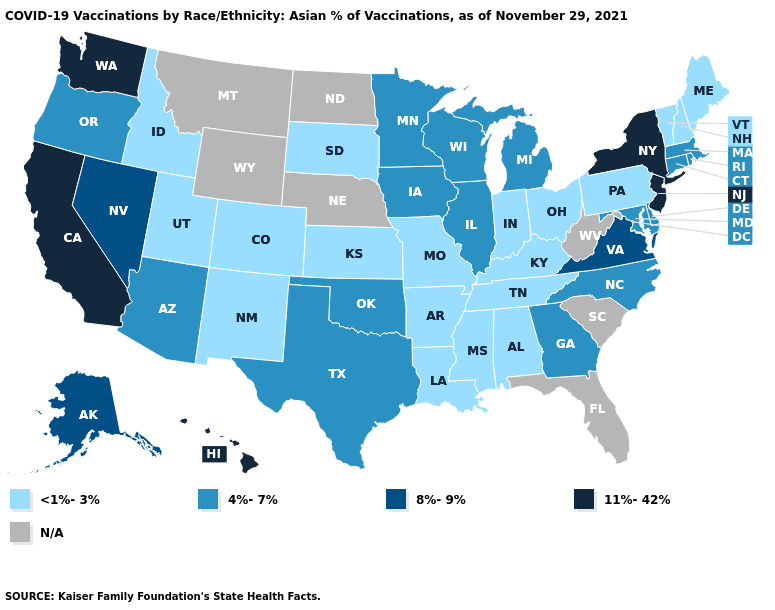Name the states that have a value in the range 4%-7%?
Answer briefly. Arizona, Connecticut, Delaware, Georgia, Illinois, Iowa, Maryland, Massachusetts, Michigan, Minnesota, North Carolina, Oklahoma, Oregon, Rhode Island, Texas, Wisconsin. What is the highest value in the MidWest ?
Answer briefly. 4%-7%. Name the states that have a value in the range N/A?
Be succinct. Florida, Montana, Nebraska, North Dakota, South Carolina, West Virginia, Wyoming. What is the value of Montana?
Keep it brief. N/A. What is the highest value in states that border Wyoming?
Give a very brief answer. <1%-3%. Is the legend a continuous bar?
Keep it brief. No. What is the highest value in the MidWest ?
Short answer required. 4%-7%. Name the states that have a value in the range N/A?
Be succinct. Florida, Montana, Nebraska, North Dakota, South Carolina, West Virginia, Wyoming. What is the lowest value in the South?
Keep it brief. <1%-3%. Is the legend a continuous bar?
Quick response, please. No. What is the value of Hawaii?
Write a very short answer. 11%-42%. Does the map have missing data?
Write a very short answer. Yes. What is the value of Oregon?
Write a very short answer. 4%-7%. 